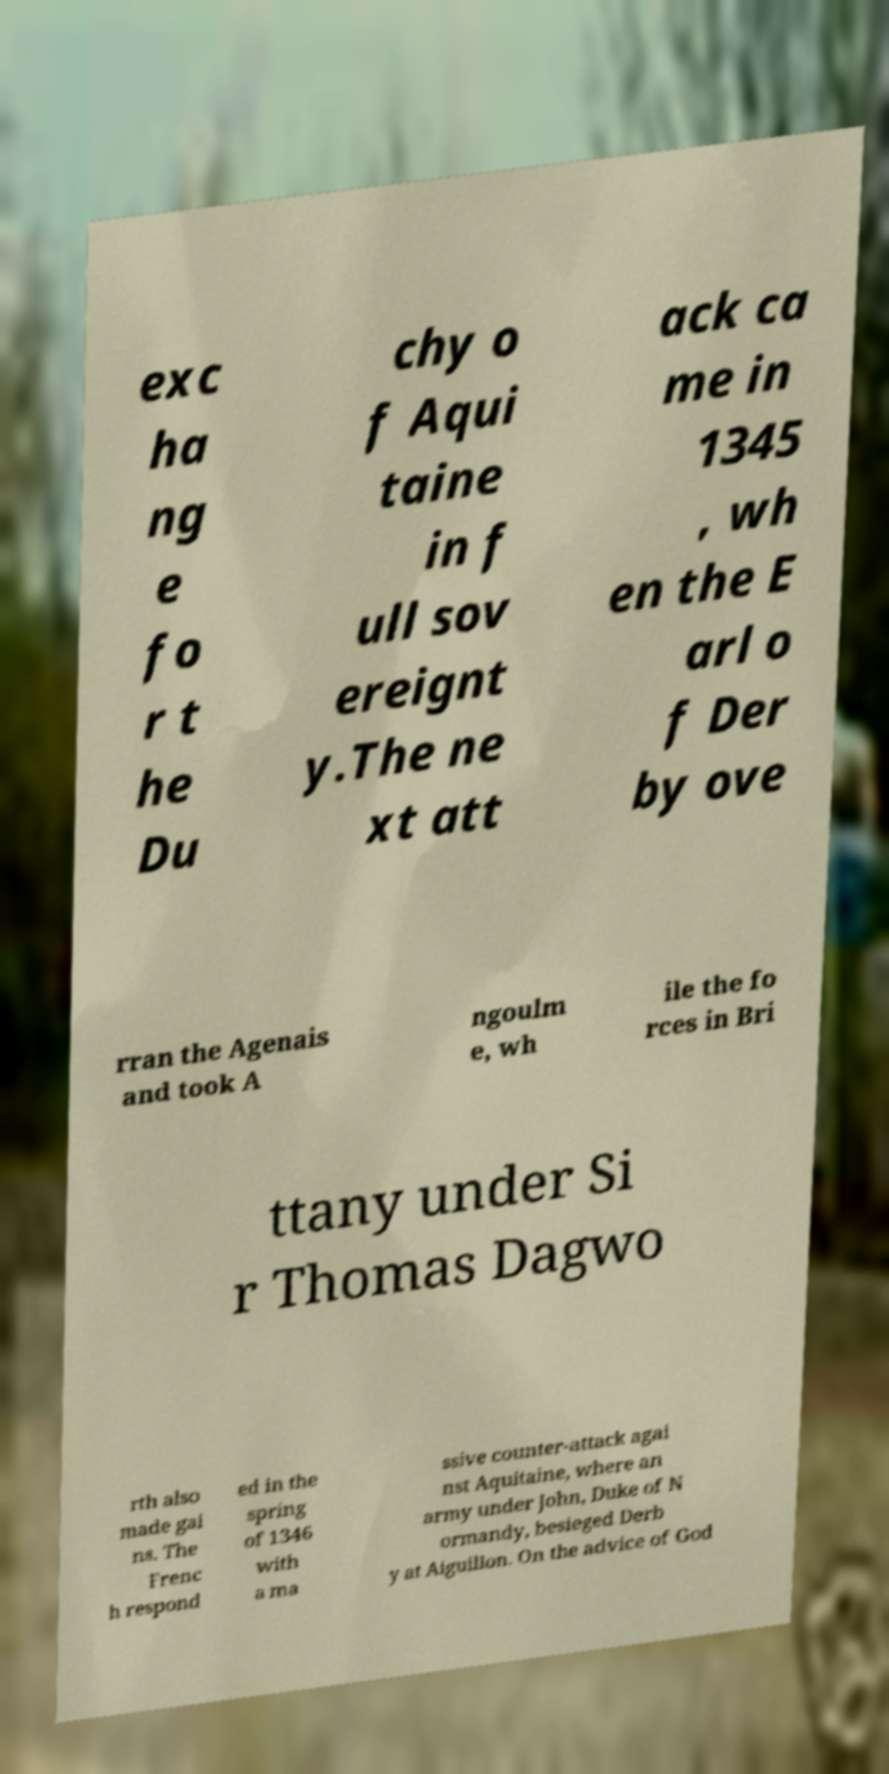There's text embedded in this image that I need extracted. Can you transcribe it verbatim? exc ha ng e fo r t he Du chy o f Aqui taine in f ull sov ereignt y.The ne xt att ack ca me in 1345 , wh en the E arl o f Der by ove rran the Agenais and took A ngoulm e, wh ile the fo rces in Bri ttany under Si r Thomas Dagwo rth also made gai ns. The Frenc h respond ed in the spring of 1346 with a ma ssive counter-attack agai nst Aquitaine, where an army under John, Duke of N ormandy, besieged Derb y at Aiguillon. On the advice of God 